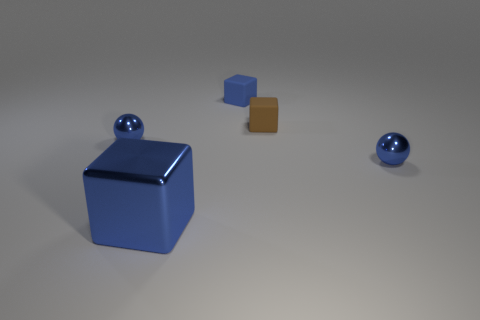There is a rubber object that is the same size as the brown block; what shape is it?
Your answer should be compact. Cube. What number of things are balls that are in front of the small brown rubber thing or tiny objects on the left side of the small brown matte cube?
Ensure brevity in your answer.  3. Is the number of matte objects less than the number of large blue cubes?
Your answer should be compact. No. There is a brown cube that is the same size as the blue matte block; what is it made of?
Offer a very short reply. Rubber. There is a blue rubber thing that is behind the large metallic thing; is its size the same as the blue thing that is left of the large blue metal block?
Offer a very short reply. Yes. Is there a small object made of the same material as the tiny blue block?
Provide a succinct answer. Yes. How many things are either things that are behind the large blue block or large blue cubes?
Provide a short and direct response. 5. Is the blue block that is in front of the small blue rubber thing made of the same material as the brown thing?
Offer a very short reply. No. Do the tiny brown object and the big metal object have the same shape?
Your answer should be compact. Yes. How many brown blocks are right of the blue shiny object that is to the right of the tiny blue matte object?
Give a very brief answer. 0. 